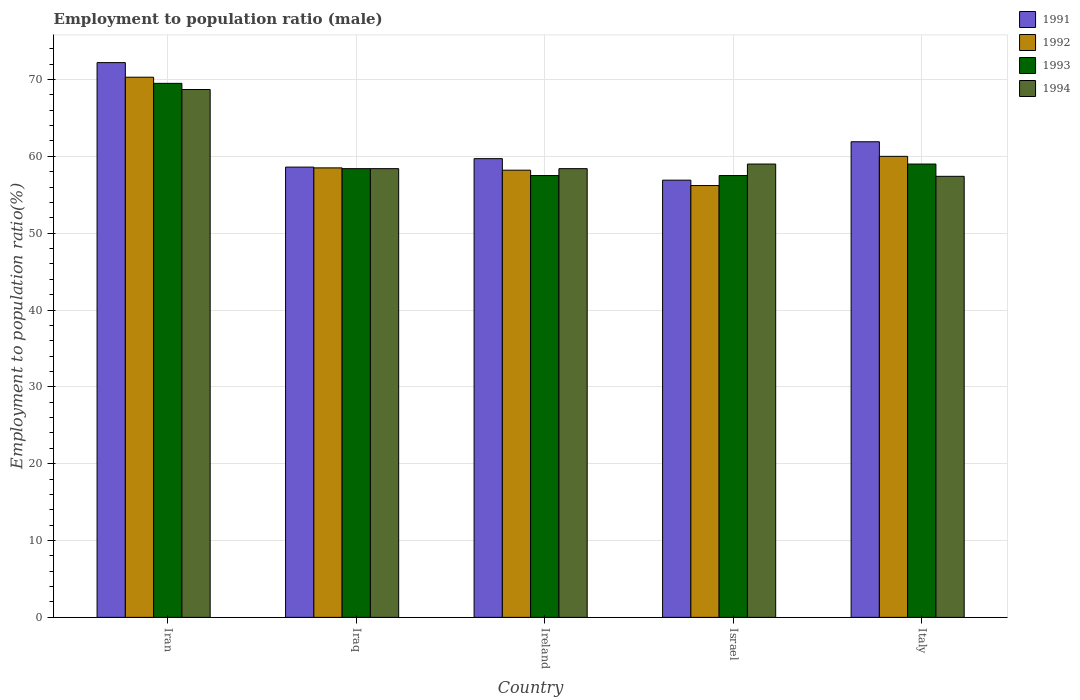How many bars are there on the 3rd tick from the right?
Give a very brief answer. 4. What is the label of the 2nd group of bars from the left?
Your answer should be very brief. Iraq. In how many cases, is the number of bars for a given country not equal to the number of legend labels?
Provide a succinct answer. 0. What is the employment to population ratio in 1993 in Italy?
Provide a succinct answer. 59. Across all countries, what is the maximum employment to population ratio in 1991?
Provide a short and direct response. 72.2. Across all countries, what is the minimum employment to population ratio in 1992?
Your answer should be compact. 56.2. In which country was the employment to population ratio in 1991 maximum?
Make the answer very short. Iran. In which country was the employment to population ratio in 1991 minimum?
Provide a short and direct response. Israel. What is the total employment to population ratio in 1994 in the graph?
Keep it short and to the point. 301.9. What is the difference between the employment to population ratio in 1994 in Iran and that in Ireland?
Keep it short and to the point. 10.3. What is the difference between the employment to population ratio in 1993 in Israel and the employment to population ratio in 1991 in Ireland?
Offer a very short reply. -2.2. What is the average employment to population ratio in 1993 per country?
Provide a succinct answer. 60.38. What is the difference between the employment to population ratio of/in 1991 and employment to population ratio of/in 1993 in Iran?
Provide a short and direct response. 2.7. What is the ratio of the employment to population ratio in 1993 in Iran to that in Ireland?
Ensure brevity in your answer.  1.21. What is the difference between the highest and the lowest employment to population ratio in 1992?
Offer a terse response. 14.1. Is the sum of the employment to population ratio in 1992 in Iraq and Israel greater than the maximum employment to population ratio in 1993 across all countries?
Your response must be concise. Yes. Is it the case that in every country, the sum of the employment to population ratio in 1994 and employment to population ratio in 1991 is greater than the sum of employment to population ratio in 1993 and employment to population ratio in 1992?
Offer a very short reply. No. What does the 1st bar from the left in Iraq represents?
Ensure brevity in your answer.  1991. What does the 1st bar from the right in Italy represents?
Give a very brief answer. 1994. Is it the case that in every country, the sum of the employment to population ratio in 1992 and employment to population ratio in 1993 is greater than the employment to population ratio in 1991?
Your answer should be compact. Yes. How many countries are there in the graph?
Make the answer very short. 5. How many legend labels are there?
Ensure brevity in your answer.  4. What is the title of the graph?
Offer a terse response. Employment to population ratio (male). What is the label or title of the X-axis?
Your answer should be compact. Country. What is the label or title of the Y-axis?
Provide a short and direct response. Employment to population ratio(%). What is the Employment to population ratio(%) in 1991 in Iran?
Provide a succinct answer. 72.2. What is the Employment to population ratio(%) in 1992 in Iran?
Provide a short and direct response. 70.3. What is the Employment to population ratio(%) in 1993 in Iran?
Provide a short and direct response. 69.5. What is the Employment to population ratio(%) in 1994 in Iran?
Offer a terse response. 68.7. What is the Employment to population ratio(%) in 1991 in Iraq?
Your answer should be very brief. 58.6. What is the Employment to population ratio(%) of 1992 in Iraq?
Offer a terse response. 58.5. What is the Employment to population ratio(%) of 1993 in Iraq?
Provide a short and direct response. 58.4. What is the Employment to population ratio(%) in 1994 in Iraq?
Provide a succinct answer. 58.4. What is the Employment to population ratio(%) of 1991 in Ireland?
Your answer should be compact. 59.7. What is the Employment to population ratio(%) of 1992 in Ireland?
Your answer should be very brief. 58.2. What is the Employment to population ratio(%) in 1993 in Ireland?
Your answer should be very brief. 57.5. What is the Employment to population ratio(%) of 1994 in Ireland?
Make the answer very short. 58.4. What is the Employment to population ratio(%) of 1991 in Israel?
Keep it short and to the point. 56.9. What is the Employment to population ratio(%) of 1992 in Israel?
Your response must be concise. 56.2. What is the Employment to population ratio(%) in 1993 in Israel?
Give a very brief answer. 57.5. What is the Employment to population ratio(%) in 1991 in Italy?
Your response must be concise. 61.9. What is the Employment to population ratio(%) in 1994 in Italy?
Keep it short and to the point. 57.4. Across all countries, what is the maximum Employment to population ratio(%) of 1991?
Offer a very short reply. 72.2. Across all countries, what is the maximum Employment to population ratio(%) in 1992?
Your response must be concise. 70.3. Across all countries, what is the maximum Employment to population ratio(%) in 1993?
Provide a short and direct response. 69.5. Across all countries, what is the maximum Employment to population ratio(%) of 1994?
Offer a terse response. 68.7. Across all countries, what is the minimum Employment to population ratio(%) in 1991?
Give a very brief answer. 56.9. Across all countries, what is the minimum Employment to population ratio(%) of 1992?
Ensure brevity in your answer.  56.2. Across all countries, what is the minimum Employment to population ratio(%) in 1993?
Your answer should be compact. 57.5. Across all countries, what is the minimum Employment to population ratio(%) in 1994?
Give a very brief answer. 57.4. What is the total Employment to population ratio(%) in 1991 in the graph?
Provide a short and direct response. 309.3. What is the total Employment to population ratio(%) of 1992 in the graph?
Your response must be concise. 303.2. What is the total Employment to population ratio(%) in 1993 in the graph?
Provide a short and direct response. 301.9. What is the total Employment to population ratio(%) of 1994 in the graph?
Your answer should be compact. 301.9. What is the difference between the Employment to population ratio(%) of 1991 in Iran and that in Iraq?
Provide a short and direct response. 13.6. What is the difference between the Employment to population ratio(%) in 1992 in Iran and that in Iraq?
Provide a short and direct response. 11.8. What is the difference between the Employment to population ratio(%) in 1991 in Iran and that in Ireland?
Your answer should be compact. 12.5. What is the difference between the Employment to population ratio(%) of 1992 in Iran and that in Ireland?
Make the answer very short. 12.1. What is the difference between the Employment to population ratio(%) of 1994 in Iran and that in Ireland?
Give a very brief answer. 10.3. What is the difference between the Employment to population ratio(%) in 1991 in Iran and that in Israel?
Provide a short and direct response. 15.3. What is the difference between the Employment to population ratio(%) in 1993 in Iran and that in Israel?
Provide a short and direct response. 12. What is the difference between the Employment to population ratio(%) in 1992 in Iran and that in Italy?
Your response must be concise. 10.3. What is the difference between the Employment to population ratio(%) of 1993 in Iran and that in Italy?
Offer a very short reply. 10.5. What is the difference between the Employment to population ratio(%) of 1994 in Iran and that in Italy?
Provide a short and direct response. 11.3. What is the difference between the Employment to population ratio(%) of 1991 in Iraq and that in Ireland?
Provide a short and direct response. -1.1. What is the difference between the Employment to population ratio(%) in 1992 in Iraq and that in Ireland?
Your answer should be very brief. 0.3. What is the difference between the Employment to population ratio(%) in 1994 in Iraq and that in Ireland?
Provide a succinct answer. 0. What is the difference between the Employment to population ratio(%) in 1991 in Iraq and that in Italy?
Offer a terse response. -3.3. What is the difference between the Employment to population ratio(%) of 1992 in Iraq and that in Italy?
Ensure brevity in your answer.  -1.5. What is the difference between the Employment to population ratio(%) in 1994 in Iraq and that in Italy?
Your answer should be compact. 1. What is the difference between the Employment to population ratio(%) in 1992 in Ireland and that in Israel?
Make the answer very short. 2. What is the difference between the Employment to population ratio(%) of 1994 in Ireland and that in Italy?
Give a very brief answer. 1. What is the difference between the Employment to population ratio(%) in 1991 in Israel and that in Italy?
Keep it short and to the point. -5. What is the difference between the Employment to population ratio(%) in 1993 in Israel and that in Italy?
Keep it short and to the point. -1.5. What is the difference between the Employment to population ratio(%) in 1992 in Iran and the Employment to population ratio(%) in 1993 in Iraq?
Make the answer very short. 11.9. What is the difference between the Employment to population ratio(%) of 1992 in Iran and the Employment to population ratio(%) of 1994 in Iraq?
Ensure brevity in your answer.  11.9. What is the difference between the Employment to population ratio(%) of 1991 in Iran and the Employment to population ratio(%) of 1993 in Ireland?
Make the answer very short. 14.7. What is the difference between the Employment to population ratio(%) of 1992 in Iran and the Employment to population ratio(%) of 1993 in Ireland?
Keep it short and to the point. 12.8. What is the difference between the Employment to population ratio(%) in 1992 in Iran and the Employment to population ratio(%) in 1994 in Ireland?
Ensure brevity in your answer.  11.9. What is the difference between the Employment to population ratio(%) in 1993 in Iran and the Employment to population ratio(%) in 1994 in Israel?
Ensure brevity in your answer.  10.5. What is the difference between the Employment to population ratio(%) in 1991 in Iran and the Employment to population ratio(%) in 1993 in Italy?
Provide a short and direct response. 13.2. What is the difference between the Employment to population ratio(%) in 1991 in Iran and the Employment to population ratio(%) in 1994 in Italy?
Make the answer very short. 14.8. What is the difference between the Employment to population ratio(%) in 1991 in Iraq and the Employment to population ratio(%) in 1992 in Ireland?
Your answer should be compact. 0.4. What is the difference between the Employment to population ratio(%) of 1991 in Iraq and the Employment to population ratio(%) of 1993 in Ireland?
Offer a terse response. 1.1. What is the difference between the Employment to population ratio(%) of 1991 in Iraq and the Employment to population ratio(%) of 1992 in Israel?
Your response must be concise. 2.4. What is the difference between the Employment to population ratio(%) of 1992 in Iraq and the Employment to population ratio(%) of 1994 in Israel?
Keep it short and to the point. -0.5. What is the difference between the Employment to population ratio(%) of 1993 in Iraq and the Employment to population ratio(%) of 1994 in Israel?
Provide a short and direct response. -0.6. What is the difference between the Employment to population ratio(%) of 1991 in Iraq and the Employment to population ratio(%) of 1992 in Italy?
Give a very brief answer. -1.4. What is the difference between the Employment to population ratio(%) of 1991 in Iraq and the Employment to population ratio(%) of 1994 in Italy?
Provide a short and direct response. 1.2. What is the difference between the Employment to population ratio(%) in 1993 in Iraq and the Employment to population ratio(%) in 1994 in Italy?
Your answer should be compact. 1. What is the difference between the Employment to population ratio(%) of 1991 in Ireland and the Employment to population ratio(%) of 1992 in Israel?
Ensure brevity in your answer.  3.5. What is the difference between the Employment to population ratio(%) of 1991 in Ireland and the Employment to population ratio(%) of 1993 in Israel?
Make the answer very short. 2.2. What is the difference between the Employment to population ratio(%) of 1991 in Ireland and the Employment to population ratio(%) of 1994 in Israel?
Your answer should be very brief. 0.7. What is the difference between the Employment to population ratio(%) in 1992 in Ireland and the Employment to population ratio(%) in 1993 in Israel?
Make the answer very short. 0.7. What is the difference between the Employment to population ratio(%) in 1991 in Ireland and the Employment to population ratio(%) in 1992 in Italy?
Provide a succinct answer. -0.3. What is the difference between the Employment to population ratio(%) of 1991 in Ireland and the Employment to population ratio(%) of 1993 in Italy?
Provide a succinct answer. 0.7. What is the difference between the Employment to population ratio(%) of 1991 in Ireland and the Employment to population ratio(%) of 1994 in Italy?
Your answer should be compact. 2.3. What is the difference between the Employment to population ratio(%) of 1992 in Ireland and the Employment to population ratio(%) of 1994 in Italy?
Provide a succinct answer. 0.8. What is the difference between the Employment to population ratio(%) of 1991 in Israel and the Employment to population ratio(%) of 1992 in Italy?
Ensure brevity in your answer.  -3.1. What is the difference between the Employment to population ratio(%) of 1991 in Israel and the Employment to population ratio(%) of 1993 in Italy?
Your answer should be very brief. -2.1. What is the difference between the Employment to population ratio(%) in 1991 in Israel and the Employment to population ratio(%) in 1994 in Italy?
Offer a very short reply. -0.5. What is the difference between the Employment to population ratio(%) of 1992 in Israel and the Employment to population ratio(%) of 1993 in Italy?
Make the answer very short. -2.8. What is the difference between the Employment to population ratio(%) of 1992 in Israel and the Employment to population ratio(%) of 1994 in Italy?
Make the answer very short. -1.2. What is the average Employment to population ratio(%) in 1991 per country?
Give a very brief answer. 61.86. What is the average Employment to population ratio(%) of 1992 per country?
Ensure brevity in your answer.  60.64. What is the average Employment to population ratio(%) of 1993 per country?
Give a very brief answer. 60.38. What is the average Employment to population ratio(%) in 1994 per country?
Keep it short and to the point. 60.38. What is the difference between the Employment to population ratio(%) of 1991 and Employment to population ratio(%) of 1992 in Iran?
Provide a succinct answer. 1.9. What is the difference between the Employment to population ratio(%) of 1992 and Employment to population ratio(%) of 1994 in Iran?
Ensure brevity in your answer.  1.6. What is the difference between the Employment to population ratio(%) of 1991 and Employment to population ratio(%) of 1992 in Iraq?
Give a very brief answer. 0.1. What is the difference between the Employment to population ratio(%) in 1991 and Employment to population ratio(%) in 1992 in Ireland?
Make the answer very short. 1.5. What is the difference between the Employment to population ratio(%) of 1991 and Employment to population ratio(%) of 1994 in Ireland?
Your answer should be very brief. 1.3. What is the difference between the Employment to population ratio(%) of 1992 and Employment to population ratio(%) of 1993 in Ireland?
Offer a terse response. 0.7. What is the difference between the Employment to population ratio(%) of 1993 and Employment to population ratio(%) of 1994 in Ireland?
Offer a terse response. -0.9. What is the difference between the Employment to population ratio(%) of 1991 and Employment to population ratio(%) of 1993 in Israel?
Provide a succinct answer. -0.6. What is the difference between the Employment to population ratio(%) in 1992 and Employment to population ratio(%) in 1993 in Israel?
Provide a succinct answer. -1.3. What is the difference between the Employment to population ratio(%) of 1992 and Employment to population ratio(%) of 1994 in Israel?
Your response must be concise. -2.8. What is the difference between the Employment to population ratio(%) in 1993 and Employment to population ratio(%) in 1994 in Israel?
Your response must be concise. -1.5. What is the difference between the Employment to population ratio(%) of 1991 and Employment to population ratio(%) of 1992 in Italy?
Ensure brevity in your answer.  1.9. What is the difference between the Employment to population ratio(%) in 1991 and Employment to population ratio(%) in 1994 in Italy?
Provide a succinct answer. 4.5. What is the difference between the Employment to population ratio(%) of 1992 and Employment to population ratio(%) of 1994 in Italy?
Your response must be concise. 2.6. What is the ratio of the Employment to population ratio(%) in 1991 in Iran to that in Iraq?
Your answer should be compact. 1.23. What is the ratio of the Employment to population ratio(%) of 1992 in Iran to that in Iraq?
Your response must be concise. 1.2. What is the ratio of the Employment to population ratio(%) in 1993 in Iran to that in Iraq?
Your answer should be compact. 1.19. What is the ratio of the Employment to population ratio(%) in 1994 in Iran to that in Iraq?
Your answer should be very brief. 1.18. What is the ratio of the Employment to population ratio(%) of 1991 in Iran to that in Ireland?
Provide a succinct answer. 1.21. What is the ratio of the Employment to population ratio(%) of 1992 in Iran to that in Ireland?
Offer a very short reply. 1.21. What is the ratio of the Employment to population ratio(%) of 1993 in Iran to that in Ireland?
Your answer should be compact. 1.21. What is the ratio of the Employment to population ratio(%) of 1994 in Iran to that in Ireland?
Give a very brief answer. 1.18. What is the ratio of the Employment to population ratio(%) of 1991 in Iran to that in Israel?
Keep it short and to the point. 1.27. What is the ratio of the Employment to population ratio(%) of 1992 in Iran to that in Israel?
Provide a succinct answer. 1.25. What is the ratio of the Employment to population ratio(%) in 1993 in Iran to that in Israel?
Ensure brevity in your answer.  1.21. What is the ratio of the Employment to population ratio(%) of 1994 in Iran to that in Israel?
Your answer should be very brief. 1.16. What is the ratio of the Employment to population ratio(%) of 1991 in Iran to that in Italy?
Keep it short and to the point. 1.17. What is the ratio of the Employment to population ratio(%) of 1992 in Iran to that in Italy?
Provide a succinct answer. 1.17. What is the ratio of the Employment to population ratio(%) in 1993 in Iran to that in Italy?
Offer a terse response. 1.18. What is the ratio of the Employment to population ratio(%) of 1994 in Iran to that in Italy?
Provide a short and direct response. 1.2. What is the ratio of the Employment to population ratio(%) of 1991 in Iraq to that in Ireland?
Offer a very short reply. 0.98. What is the ratio of the Employment to population ratio(%) of 1993 in Iraq to that in Ireland?
Provide a succinct answer. 1.02. What is the ratio of the Employment to population ratio(%) in 1994 in Iraq to that in Ireland?
Give a very brief answer. 1. What is the ratio of the Employment to population ratio(%) of 1991 in Iraq to that in Israel?
Offer a terse response. 1.03. What is the ratio of the Employment to population ratio(%) in 1992 in Iraq to that in Israel?
Your answer should be very brief. 1.04. What is the ratio of the Employment to population ratio(%) in 1993 in Iraq to that in Israel?
Your answer should be very brief. 1.02. What is the ratio of the Employment to population ratio(%) of 1991 in Iraq to that in Italy?
Offer a very short reply. 0.95. What is the ratio of the Employment to population ratio(%) in 1992 in Iraq to that in Italy?
Your response must be concise. 0.97. What is the ratio of the Employment to population ratio(%) of 1993 in Iraq to that in Italy?
Your response must be concise. 0.99. What is the ratio of the Employment to population ratio(%) in 1994 in Iraq to that in Italy?
Offer a very short reply. 1.02. What is the ratio of the Employment to population ratio(%) of 1991 in Ireland to that in Israel?
Ensure brevity in your answer.  1.05. What is the ratio of the Employment to population ratio(%) of 1992 in Ireland to that in Israel?
Ensure brevity in your answer.  1.04. What is the ratio of the Employment to population ratio(%) of 1993 in Ireland to that in Israel?
Your answer should be very brief. 1. What is the ratio of the Employment to population ratio(%) of 1991 in Ireland to that in Italy?
Keep it short and to the point. 0.96. What is the ratio of the Employment to population ratio(%) of 1993 in Ireland to that in Italy?
Offer a very short reply. 0.97. What is the ratio of the Employment to population ratio(%) in 1994 in Ireland to that in Italy?
Offer a very short reply. 1.02. What is the ratio of the Employment to population ratio(%) of 1991 in Israel to that in Italy?
Offer a very short reply. 0.92. What is the ratio of the Employment to population ratio(%) of 1992 in Israel to that in Italy?
Give a very brief answer. 0.94. What is the ratio of the Employment to population ratio(%) in 1993 in Israel to that in Italy?
Make the answer very short. 0.97. What is the ratio of the Employment to population ratio(%) of 1994 in Israel to that in Italy?
Your response must be concise. 1.03. What is the difference between the highest and the second highest Employment to population ratio(%) in 1991?
Provide a short and direct response. 10.3. What is the difference between the highest and the second highest Employment to population ratio(%) in 1994?
Offer a very short reply. 9.7. What is the difference between the highest and the lowest Employment to population ratio(%) of 1992?
Give a very brief answer. 14.1. What is the difference between the highest and the lowest Employment to population ratio(%) in 1993?
Give a very brief answer. 12. What is the difference between the highest and the lowest Employment to population ratio(%) in 1994?
Make the answer very short. 11.3. 